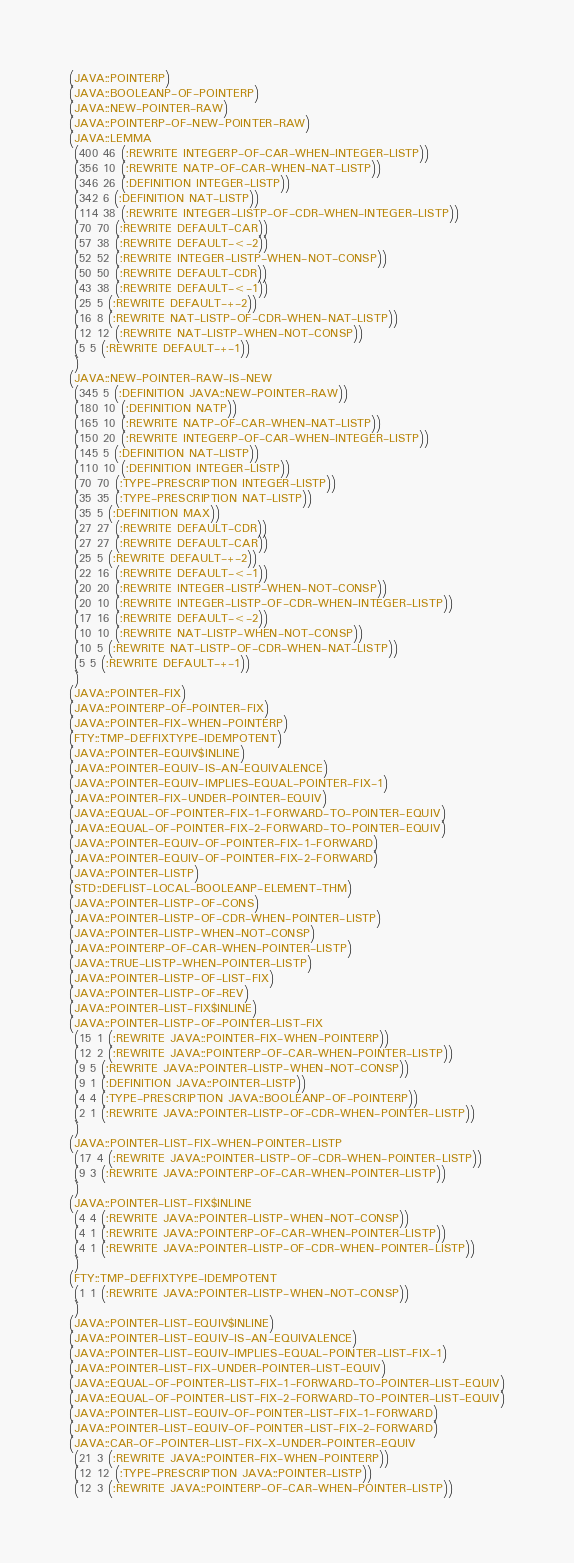Convert code to text. <code><loc_0><loc_0><loc_500><loc_500><_Lisp_>(JAVA::POINTERP)
(JAVA::BOOLEANP-OF-POINTERP)
(JAVA::NEW-POINTER-RAW)
(JAVA::POINTERP-OF-NEW-POINTER-RAW)
(JAVA::LEMMA
 (400 46 (:REWRITE INTEGERP-OF-CAR-WHEN-INTEGER-LISTP))
 (356 10 (:REWRITE NATP-OF-CAR-WHEN-NAT-LISTP))
 (346 26 (:DEFINITION INTEGER-LISTP))
 (342 6 (:DEFINITION NAT-LISTP))
 (114 38 (:REWRITE INTEGER-LISTP-OF-CDR-WHEN-INTEGER-LISTP))
 (70 70 (:REWRITE DEFAULT-CAR))
 (57 38 (:REWRITE DEFAULT-<-2))
 (52 52 (:REWRITE INTEGER-LISTP-WHEN-NOT-CONSP))
 (50 50 (:REWRITE DEFAULT-CDR))
 (43 38 (:REWRITE DEFAULT-<-1))
 (25 5 (:REWRITE DEFAULT-+-2))
 (16 8 (:REWRITE NAT-LISTP-OF-CDR-WHEN-NAT-LISTP))
 (12 12 (:REWRITE NAT-LISTP-WHEN-NOT-CONSP))
 (5 5 (:REWRITE DEFAULT-+-1))
 )
(JAVA::NEW-POINTER-RAW-IS-NEW
 (345 5 (:DEFINITION JAVA::NEW-POINTER-RAW))
 (180 10 (:DEFINITION NATP))
 (165 10 (:REWRITE NATP-OF-CAR-WHEN-NAT-LISTP))
 (150 20 (:REWRITE INTEGERP-OF-CAR-WHEN-INTEGER-LISTP))
 (145 5 (:DEFINITION NAT-LISTP))
 (110 10 (:DEFINITION INTEGER-LISTP))
 (70 70 (:TYPE-PRESCRIPTION INTEGER-LISTP))
 (35 35 (:TYPE-PRESCRIPTION NAT-LISTP))
 (35 5 (:DEFINITION MAX))
 (27 27 (:REWRITE DEFAULT-CDR))
 (27 27 (:REWRITE DEFAULT-CAR))
 (25 5 (:REWRITE DEFAULT-+-2))
 (22 16 (:REWRITE DEFAULT-<-1))
 (20 20 (:REWRITE INTEGER-LISTP-WHEN-NOT-CONSP))
 (20 10 (:REWRITE INTEGER-LISTP-OF-CDR-WHEN-INTEGER-LISTP))
 (17 16 (:REWRITE DEFAULT-<-2))
 (10 10 (:REWRITE NAT-LISTP-WHEN-NOT-CONSP))
 (10 5 (:REWRITE NAT-LISTP-OF-CDR-WHEN-NAT-LISTP))
 (5 5 (:REWRITE DEFAULT-+-1))
 )
(JAVA::POINTER-FIX)
(JAVA::POINTERP-OF-POINTER-FIX)
(JAVA::POINTER-FIX-WHEN-POINTERP)
(FTY::TMP-DEFFIXTYPE-IDEMPOTENT)
(JAVA::POINTER-EQUIV$INLINE)
(JAVA::POINTER-EQUIV-IS-AN-EQUIVALENCE)
(JAVA::POINTER-EQUIV-IMPLIES-EQUAL-POINTER-FIX-1)
(JAVA::POINTER-FIX-UNDER-POINTER-EQUIV)
(JAVA::EQUAL-OF-POINTER-FIX-1-FORWARD-TO-POINTER-EQUIV)
(JAVA::EQUAL-OF-POINTER-FIX-2-FORWARD-TO-POINTER-EQUIV)
(JAVA::POINTER-EQUIV-OF-POINTER-FIX-1-FORWARD)
(JAVA::POINTER-EQUIV-OF-POINTER-FIX-2-FORWARD)
(JAVA::POINTER-LISTP)
(STD::DEFLIST-LOCAL-BOOLEANP-ELEMENT-THM)
(JAVA::POINTER-LISTP-OF-CONS)
(JAVA::POINTER-LISTP-OF-CDR-WHEN-POINTER-LISTP)
(JAVA::POINTER-LISTP-WHEN-NOT-CONSP)
(JAVA::POINTERP-OF-CAR-WHEN-POINTER-LISTP)
(JAVA::TRUE-LISTP-WHEN-POINTER-LISTP)
(JAVA::POINTER-LISTP-OF-LIST-FIX)
(JAVA::POINTER-LISTP-OF-REV)
(JAVA::POINTER-LIST-FIX$INLINE)
(JAVA::POINTER-LISTP-OF-POINTER-LIST-FIX
 (15 1 (:REWRITE JAVA::POINTER-FIX-WHEN-POINTERP))
 (12 2 (:REWRITE JAVA::POINTERP-OF-CAR-WHEN-POINTER-LISTP))
 (9 5 (:REWRITE JAVA::POINTER-LISTP-WHEN-NOT-CONSP))
 (9 1 (:DEFINITION JAVA::POINTER-LISTP))
 (4 4 (:TYPE-PRESCRIPTION JAVA::BOOLEANP-OF-POINTERP))
 (2 1 (:REWRITE JAVA::POINTER-LISTP-OF-CDR-WHEN-POINTER-LISTP))
 )
(JAVA::POINTER-LIST-FIX-WHEN-POINTER-LISTP
 (17 4 (:REWRITE JAVA::POINTER-LISTP-OF-CDR-WHEN-POINTER-LISTP))
 (9 3 (:REWRITE JAVA::POINTERP-OF-CAR-WHEN-POINTER-LISTP))
 )
(JAVA::POINTER-LIST-FIX$INLINE
 (4 4 (:REWRITE JAVA::POINTER-LISTP-WHEN-NOT-CONSP))
 (4 1 (:REWRITE JAVA::POINTERP-OF-CAR-WHEN-POINTER-LISTP))
 (4 1 (:REWRITE JAVA::POINTER-LISTP-OF-CDR-WHEN-POINTER-LISTP))
 )
(FTY::TMP-DEFFIXTYPE-IDEMPOTENT
 (1 1 (:REWRITE JAVA::POINTER-LISTP-WHEN-NOT-CONSP))
 )
(JAVA::POINTER-LIST-EQUIV$INLINE)
(JAVA::POINTER-LIST-EQUIV-IS-AN-EQUIVALENCE)
(JAVA::POINTER-LIST-EQUIV-IMPLIES-EQUAL-POINTER-LIST-FIX-1)
(JAVA::POINTER-LIST-FIX-UNDER-POINTER-LIST-EQUIV)
(JAVA::EQUAL-OF-POINTER-LIST-FIX-1-FORWARD-TO-POINTER-LIST-EQUIV)
(JAVA::EQUAL-OF-POINTER-LIST-FIX-2-FORWARD-TO-POINTER-LIST-EQUIV)
(JAVA::POINTER-LIST-EQUIV-OF-POINTER-LIST-FIX-1-FORWARD)
(JAVA::POINTER-LIST-EQUIV-OF-POINTER-LIST-FIX-2-FORWARD)
(JAVA::CAR-OF-POINTER-LIST-FIX-X-UNDER-POINTER-EQUIV
 (21 3 (:REWRITE JAVA::POINTER-FIX-WHEN-POINTERP))
 (12 12 (:TYPE-PRESCRIPTION JAVA::POINTER-LISTP))
 (12 3 (:REWRITE JAVA::POINTERP-OF-CAR-WHEN-POINTER-LISTP))</code> 